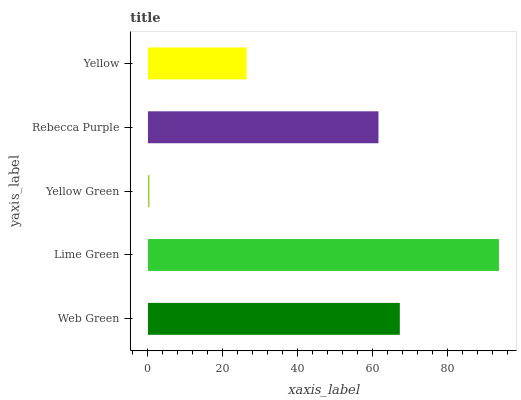Is Yellow Green the minimum?
Answer yes or no. Yes. Is Lime Green the maximum?
Answer yes or no. Yes. Is Lime Green the minimum?
Answer yes or no. No. Is Yellow Green the maximum?
Answer yes or no. No. Is Lime Green greater than Yellow Green?
Answer yes or no. Yes. Is Yellow Green less than Lime Green?
Answer yes or no. Yes. Is Yellow Green greater than Lime Green?
Answer yes or no. No. Is Lime Green less than Yellow Green?
Answer yes or no. No. Is Rebecca Purple the high median?
Answer yes or no. Yes. Is Rebecca Purple the low median?
Answer yes or no. Yes. Is Yellow the high median?
Answer yes or no. No. Is Web Green the low median?
Answer yes or no. No. 